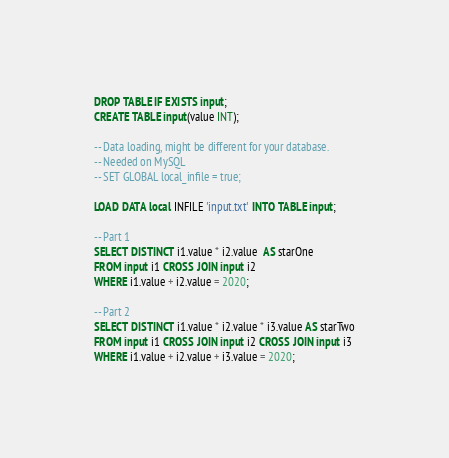<code> <loc_0><loc_0><loc_500><loc_500><_SQL_>DROP TABLE IF EXISTS input;
CREATE TABLE input(value INT);

-- Data loading, might be different for your database.
-- Needed on MySQL
-- SET GLOBAL local_infile = true;

LOAD DATA local INFILE 'input.txt' INTO TABLE input;

-- Part 1
SELECT DISTINCT i1.value * i2.value  AS starOne
FROM input i1 CROSS JOIN input i2
WHERE i1.value + i2.value = 2020;

-- Part 2
SELECT DISTINCT i1.value * i2.value * i3.value AS starTwo
FROM input i1 CROSS JOIN input i2 CROSS JOIN input i3
WHERE i1.value + i2.value + i3.value = 2020;
</code> 